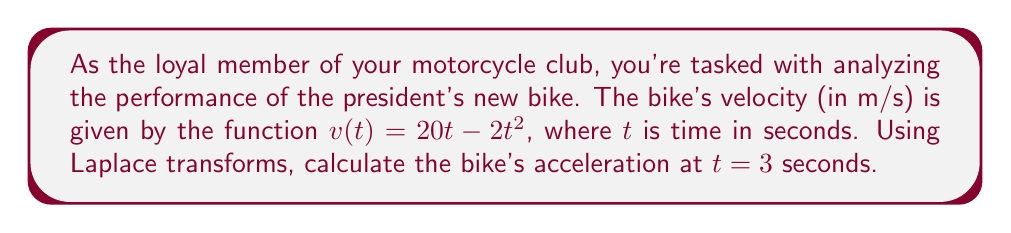Provide a solution to this math problem. To solve this problem using Laplace transforms, we'll follow these steps:

1) First, recall that acceleration is the derivative of velocity. So, we need to find $a(t) = \frac{d}{dt}v(t)$.

2) Let's take the Laplace transform of both sides of the equation $v(t) = 20t - 2t^2$:

   $$\mathcal{L}\{v(t)\} = \mathcal{L}\{20t - 2t^2\}$$

3) Using Laplace transform properties:

   $$V(s) = 20 \cdot \frac{1}{s^2} - 2 \cdot \frac{2}{s^3} = \frac{20}{s^2} - \frac{4}{s^3}$$

4) To find acceleration, we need to multiply $V(s)$ by $s^2$ (which corresponds to taking the second derivative in the time domain):

   $$s^2V(s) = s^2 \cdot (\frac{20}{s^2} - \frac{4}{s^3}) = 20 - \frac{4}{s}$$

5) Now, let's take the inverse Laplace transform:

   $$\mathcal{L}^{-1}\{s^2V(s)\} = \mathcal{L}^{-1}\{20 - \frac{4}{s}\} = 20 - 4$$

6) Therefore, the acceleration function is:

   $$a(t) = 20 - 4 = 16$$

7) The acceleration is constant and equal to 16 m/s^2 for all t, including at t = 3 seconds.
Answer: The acceleration of the president's bike at $t = 3$ seconds is 16 m/s^2. 